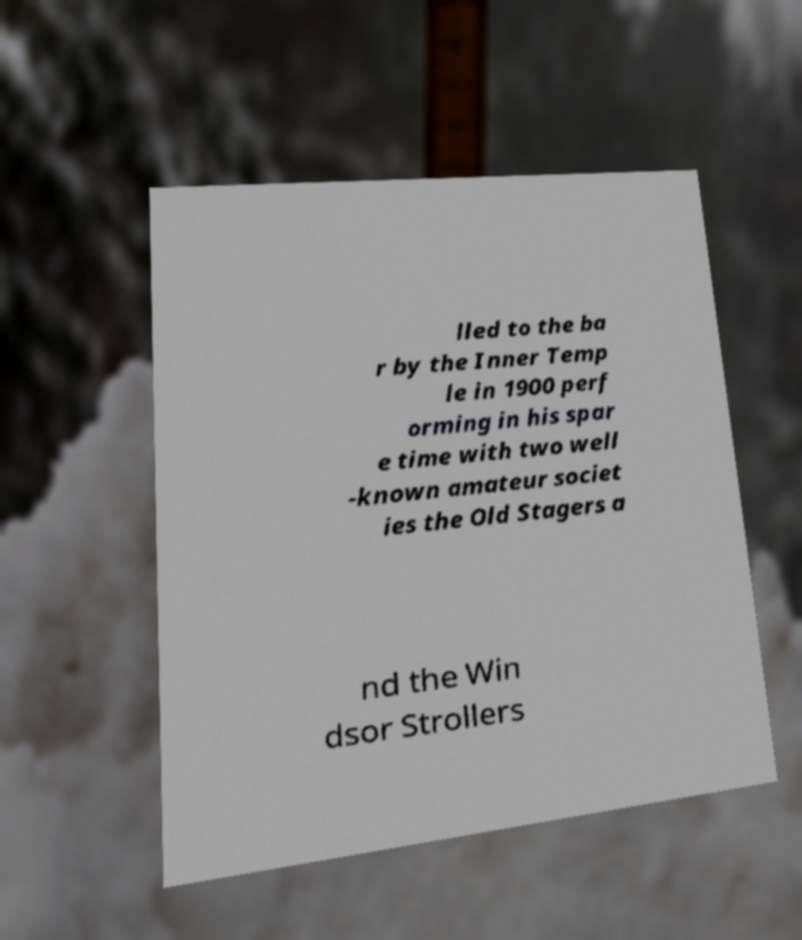For documentation purposes, I need the text within this image transcribed. Could you provide that? lled to the ba r by the Inner Temp le in 1900 perf orming in his spar e time with two well -known amateur societ ies the Old Stagers a nd the Win dsor Strollers 